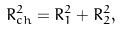Convert formula to latex. <formula><loc_0><loc_0><loc_500><loc_500>R _ { c h } ^ { 2 } = R _ { 1 } ^ { 2 } + R _ { 2 } ^ { 2 } ,</formula> 